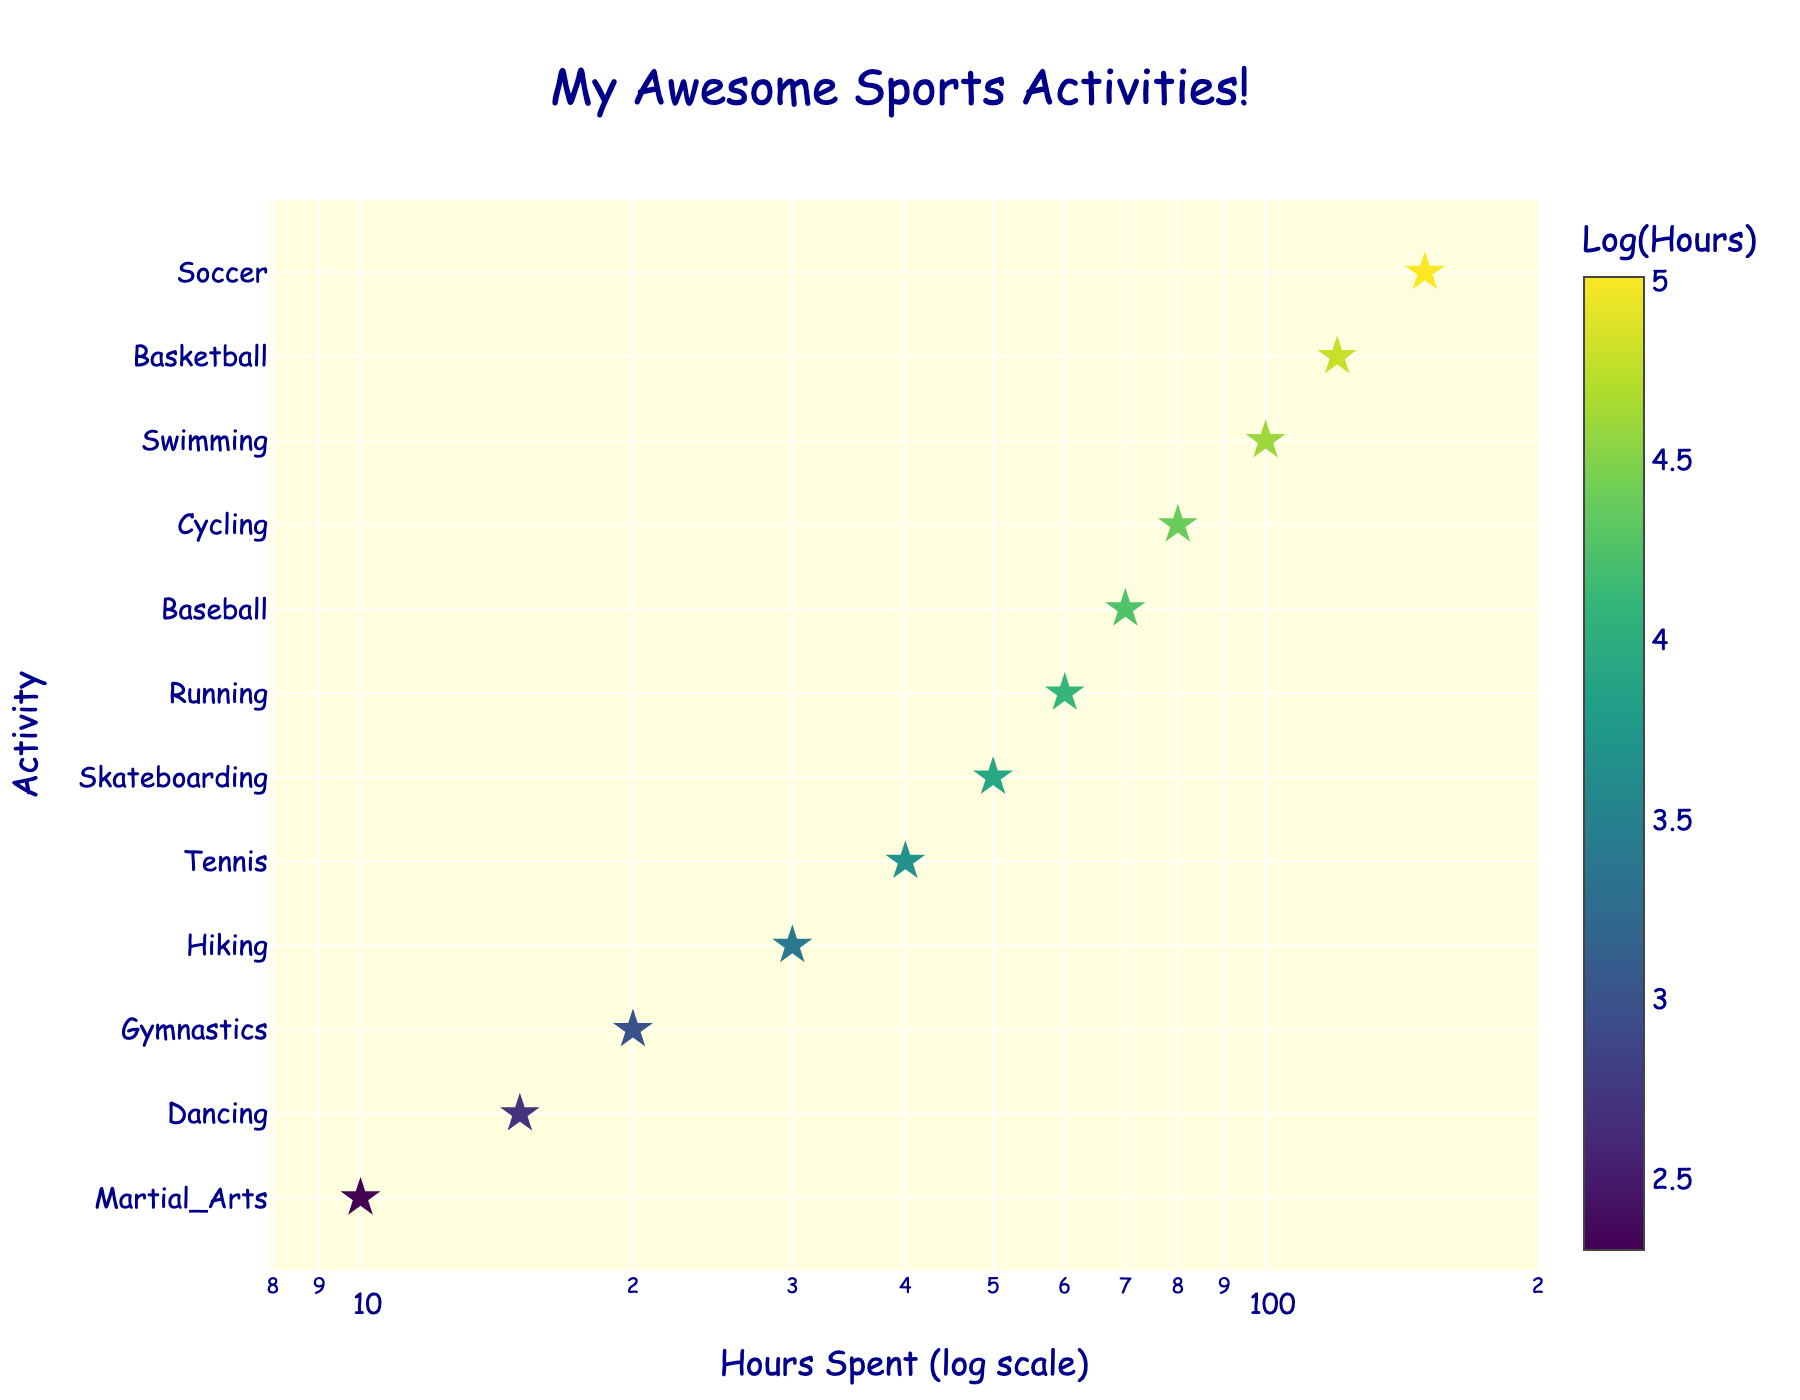What is the title of the figure? The title is usually found at the top of a figure. The title provides a quick understanding of what the data represents. In this case, it describes various sports activities and the time spent on each.
Answer: My Awesome Sports Activities! Which activity has the highest number of hours spent? Look for the data point with the greatest x-value, as the x-axis represents hours spent. The farthest to the right on the x-axis indicates the highest number of hours.
Answer: Soccer Which activity has the least number of hours spent? Look for the data point with the smallest x-value, as the x-axis represents hours spent. The farthest to the left on the x-axis indicates the lowest number of hours.
Answer: Martial_Arts How many activities are included in the figure? Count the number of unique y-axis labels, as each represents a different activity.
Answer: 12 What is the color of the data points related to? The color of each data point varies based on a value. In this figure, it’s related to the logarithm of hours spent, with the color bar explaining the gradient from lower to higher values.
Answer: Log of hours spent Which activities have more than 100 hours spent? Identify the data points with x values greater than 100. This involves looking for points right of the 100-hour mark on the log-scaled x-axis.
Answer: Soccer, Basketball What's the average number of hours spent on Soccer and Basketball? First note the hours spent on Soccer and Basketball (150 and 120 respectively). Sum them up and divide by 2 for the average: (150 + 120) / 2.
Answer: 135 How does the time spent on Gymnastics compare to Baseball? Look at the y-axis for Gymnastics and Baseball, then compare their x values (time spent). Gymnastics has 20 hours and Baseball has 70 hours, so Baseball has more.
Answer: Baseball has more hours Which two activities have the closest amount of time spent? Find pairs of activities with the smallest difference in x values. By observation, look for data points closest to each other horizontally.
Answer: Gymnastics and Dancing How many activities have time spent between 30 to 80 hours? Identify the data points that fall in the range from 30 to 80 on the x-axis. This includes activities like Tennis, Baseball, and Running.
Answer: 3 